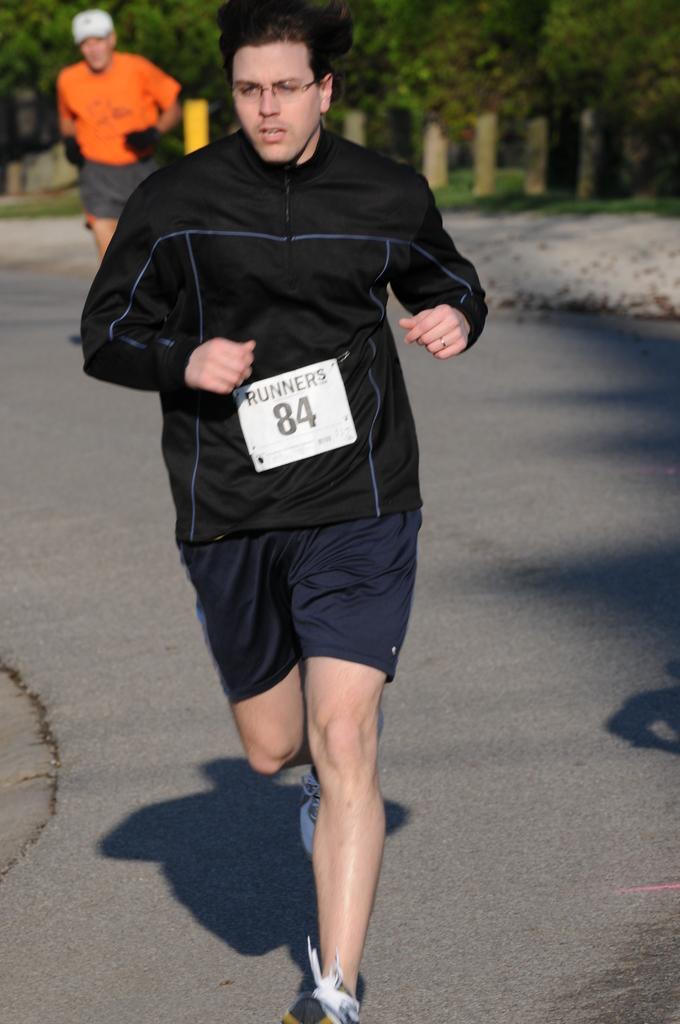In one or two sentences, can you explain what this image depicts? In this image we can see many trees. There are two persons running on the road. There is a shadow of a person in the image. There is a grassy land in the image. There is a badge attached to a dress. 